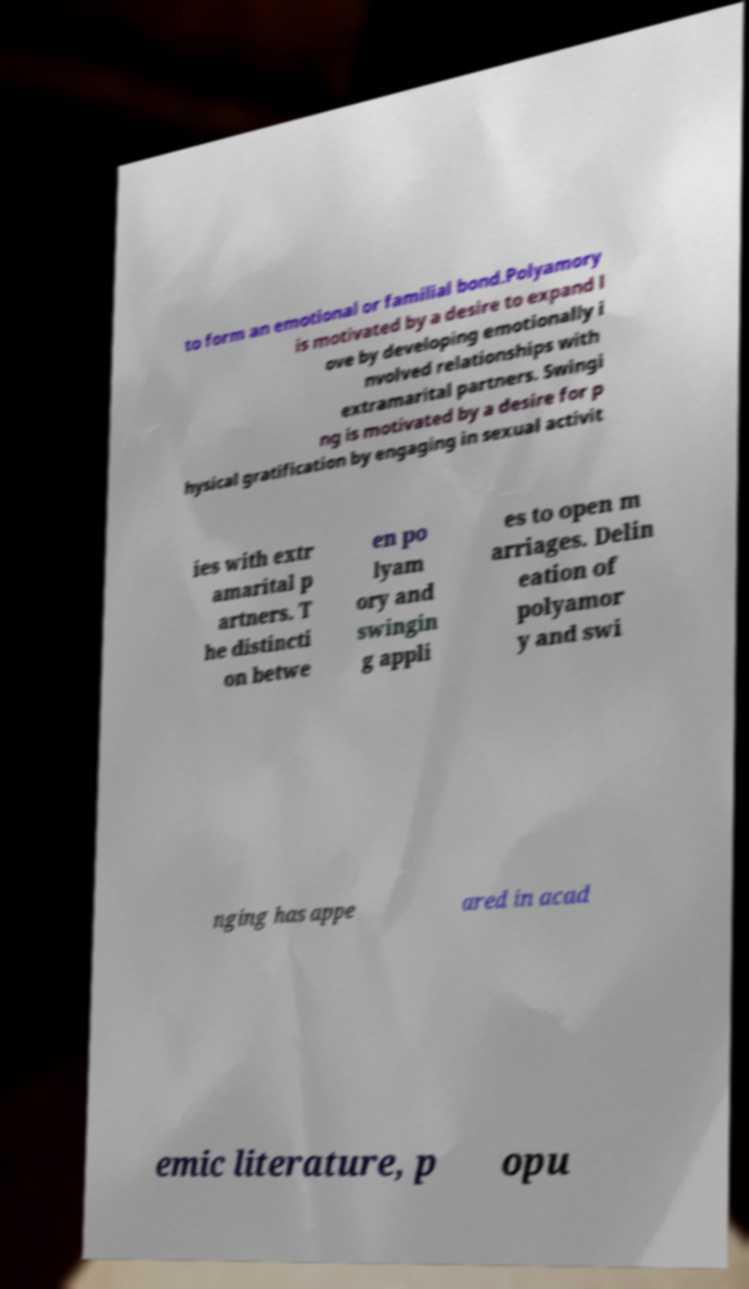Can you accurately transcribe the text from the provided image for me? to form an emotional or familial bond.Polyamory is motivated by a desire to expand l ove by developing emotionally i nvolved relationships with extramarital partners. Swingi ng is motivated by a desire for p hysical gratification by engaging in sexual activit ies with extr amarital p artners. T he distincti on betwe en po lyam ory and swingin g appli es to open m arriages. Delin eation of polyamor y and swi nging has appe ared in acad emic literature, p opu 